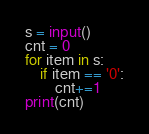Convert code to text. <code><loc_0><loc_0><loc_500><loc_500><_Python_>s = input()
cnt = 0
for item in s:
    if item == '0':
        cnt+=1
print(cnt)
</code> 